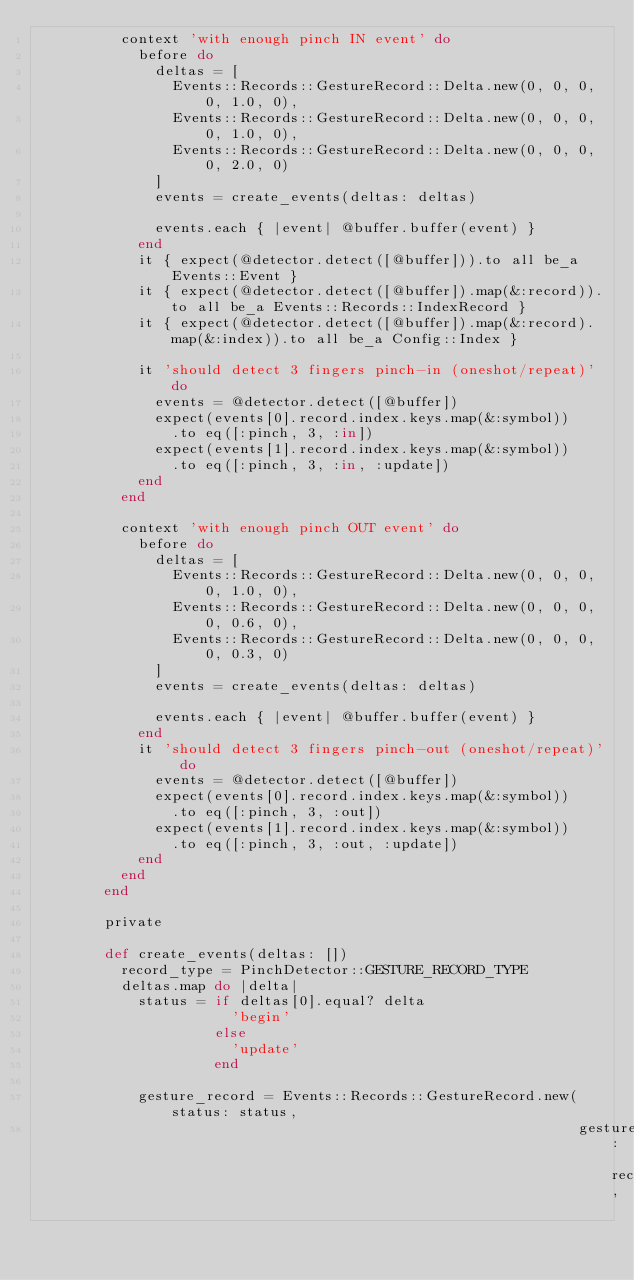<code> <loc_0><loc_0><loc_500><loc_500><_Ruby_>          context 'with enough pinch IN event' do
            before do
              deltas = [
                Events::Records::GestureRecord::Delta.new(0, 0, 0, 0, 1.0, 0),
                Events::Records::GestureRecord::Delta.new(0, 0, 0, 0, 1.0, 0),
                Events::Records::GestureRecord::Delta.new(0, 0, 0, 0, 2.0, 0)
              ]
              events = create_events(deltas: deltas)

              events.each { |event| @buffer.buffer(event) }
            end
            it { expect(@detector.detect([@buffer])).to all be_a Events::Event }
            it { expect(@detector.detect([@buffer]).map(&:record)).to all be_a Events::Records::IndexRecord }
            it { expect(@detector.detect([@buffer]).map(&:record).map(&:index)).to all be_a Config::Index }

            it 'should detect 3 fingers pinch-in (oneshot/repeat)' do
              events = @detector.detect([@buffer])
              expect(events[0].record.index.keys.map(&:symbol))
                .to eq([:pinch, 3, :in])
              expect(events[1].record.index.keys.map(&:symbol))
                .to eq([:pinch, 3, :in, :update])
            end
          end

          context 'with enough pinch OUT event' do
            before do
              deltas = [
                Events::Records::GestureRecord::Delta.new(0, 0, 0, 0, 1.0, 0),
                Events::Records::GestureRecord::Delta.new(0, 0, 0, 0, 0.6, 0),
                Events::Records::GestureRecord::Delta.new(0, 0, 0, 0, 0.3, 0)
              ]
              events = create_events(deltas: deltas)

              events.each { |event| @buffer.buffer(event) }
            end
            it 'should detect 3 fingers pinch-out (oneshot/repeat)' do
              events = @detector.detect([@buffer])
              expect(events[0].record.index.keys.map(&:symbol))
                .to eq([:pinch, 3, :out])
              expect(events[1].record.index.keys.map(&:symbol))
                .to eq([:pinch, 3, :out, :update])
            end
          end
        end

        private

        def create_events(deltas: [])
          record_type = PinchDetector::GESTURE_RECORD_TYPE
          deltas.map do |delta|
            status = if deltas[0].equal? delta
                       'begin'
                     else
                       'update'
                     end

            gesture_record = Events::Records::GestureRecord.new(status: status,
                                                                gesture: record_type,</code> 